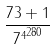Convert formula to latex. <formula><loc_0><loc_0><loc_500><loc_500>\frac { 7 3 + 1 } { { 7 ^ { 4 } } ^ { 2 8 0 } }</formula> 